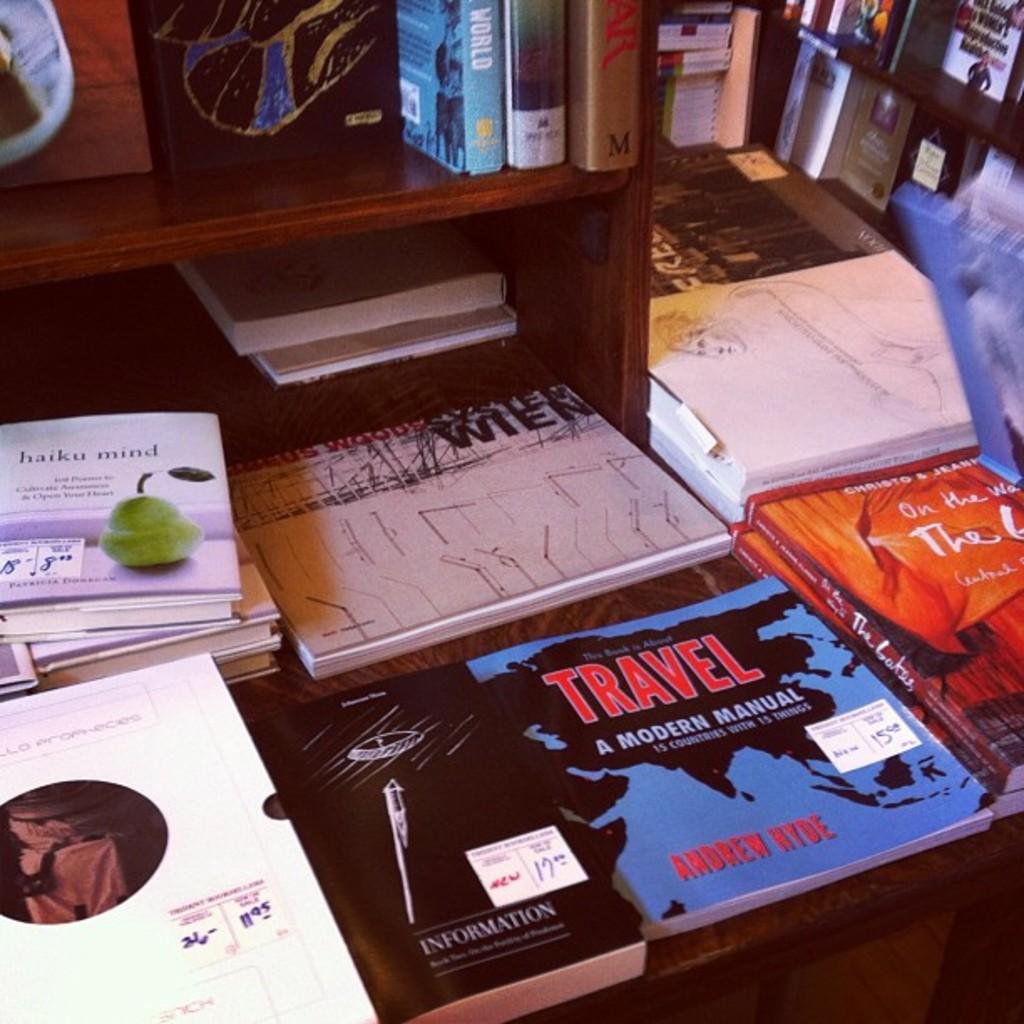What kind of modern manual is the blue book?
Ensure brevity in your answer.  Travel. 